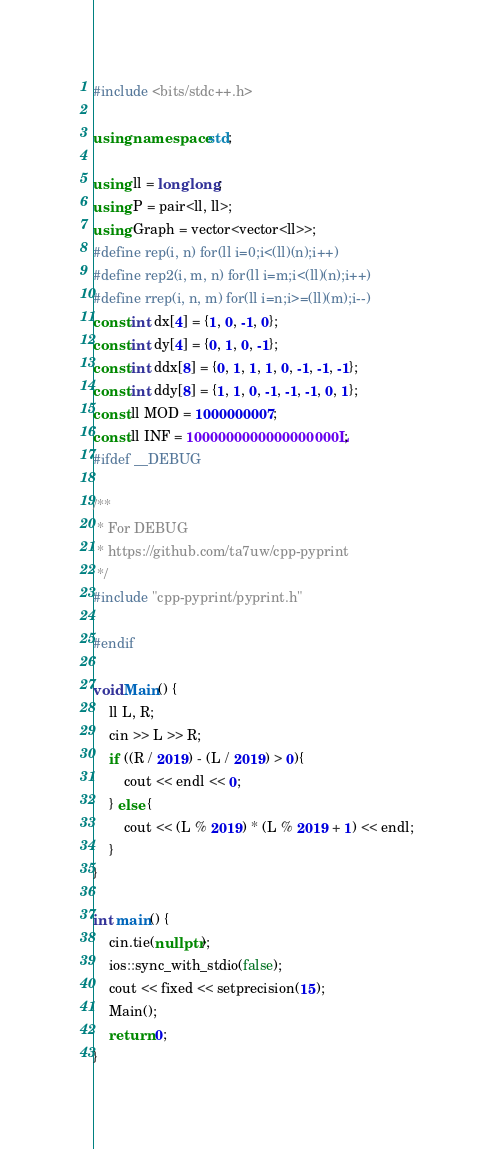<code> <loc_0><loc_0><loc_500><loc_500><_C++_>#include <bits/stdc++.h>

using namespace std;

using ll = long long;
using P = pair<ll, ll>;
using Graph = vector<vector<ll>>;
#define rep(i, n) for(ll i=0;i<(ll)(n);i++)
#define rep2(i, m, n) for(ll i=m;i<(ll)(n);i++)
#define rrep(i, n, m) for(ll i=n;i>=(ll)(m);i--)
const int dx[4] = {1, 0, -1, 0};
const int dy[4] = {0, 1, 0, -1};
const int ddx[8] = {0, 1, 1, 1, 0, -1, -1, -1};
const int ddy[8] = {1, 1, 0, -1, -1, -1, 0, 1};
const ll MOD = 1000000007;
const ll INF = 1000000000000000000L;
#ifdef __DEBUG

/**
 * For DEBUG
 * https://github.com/ta7uw/cpp-pyprint
 */
#include "cpp-pyprint/pyprint.h"

#endif

void Main() {
    ll L, R;
    cin >> L >> R;
    if ((R / 2019) - (L / 2019) > 0){
        cout << endl << 0;
    } else {
        cout << (L % 2019) * (L % 2019 + 1) << endl;
    }
}

int main() {
    cin.tie(nullptr);
    ios::sync_with_stdio(false);
    cout << fixed << setprecision(15);
    Main();
    return 0;
}
</code> 